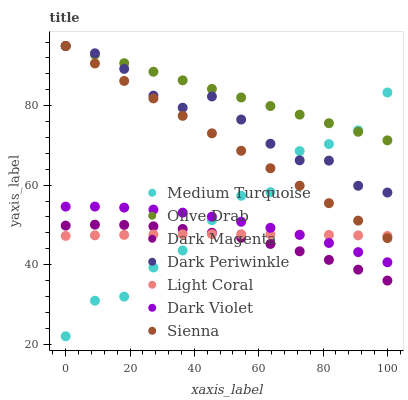Does Dark Magenta have the minimum area under the curve?
Answer yes or no. Yes. Does Olive Drab have the maximum area under the curve?
Answer yes or no. Yes. Does Dark Violet have the minimum area under the curve?
Answer yes or no. No. Does Dark Violet have the maximum area under the curve?
Answer yes or no. No. Is Olive Drab the smoothest?
Answer yes or no. Yes. Is Medium Turquoise the roughest?
Answer yes or no. Yes. Is Dark Magenta the smoothest?
Answer yes or no. No. Is Dark Magenta the roughest?
Answer yes or no. No. Does Medium Turquoise have the lowest value?
Answer yes or no. Yes. Does Dark Magenta have the lowest value?
Answer yes or no. No. Does Olive Drab have the highest value?
Answer yes or no. Yes. Does Dark Magenta have the highest value?
Answer yes or no. No. Is Dark Violet less than Sienna?
Answer yes or no. Yes. Is Dark Violet greater than Dark Magenta?
Answer yes or no. Yes. Does Dark Periwinkle intersect Sienna?
Answer yes or no. Yes. Is Dark Periwinkle less than Sienna?
Answer yes or no. No. Is Dark Periwinkle greater than Sienna?
Answer yes or no. No. Does Dark Violet intersect Sienna?
Answer yes or no. No. 